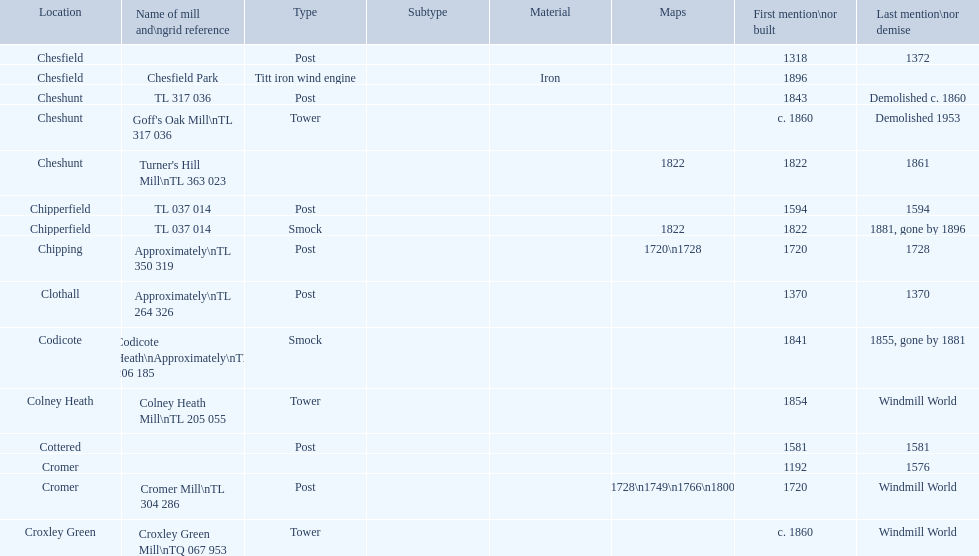How many mills were built or first mentioned after 1800? 8. 